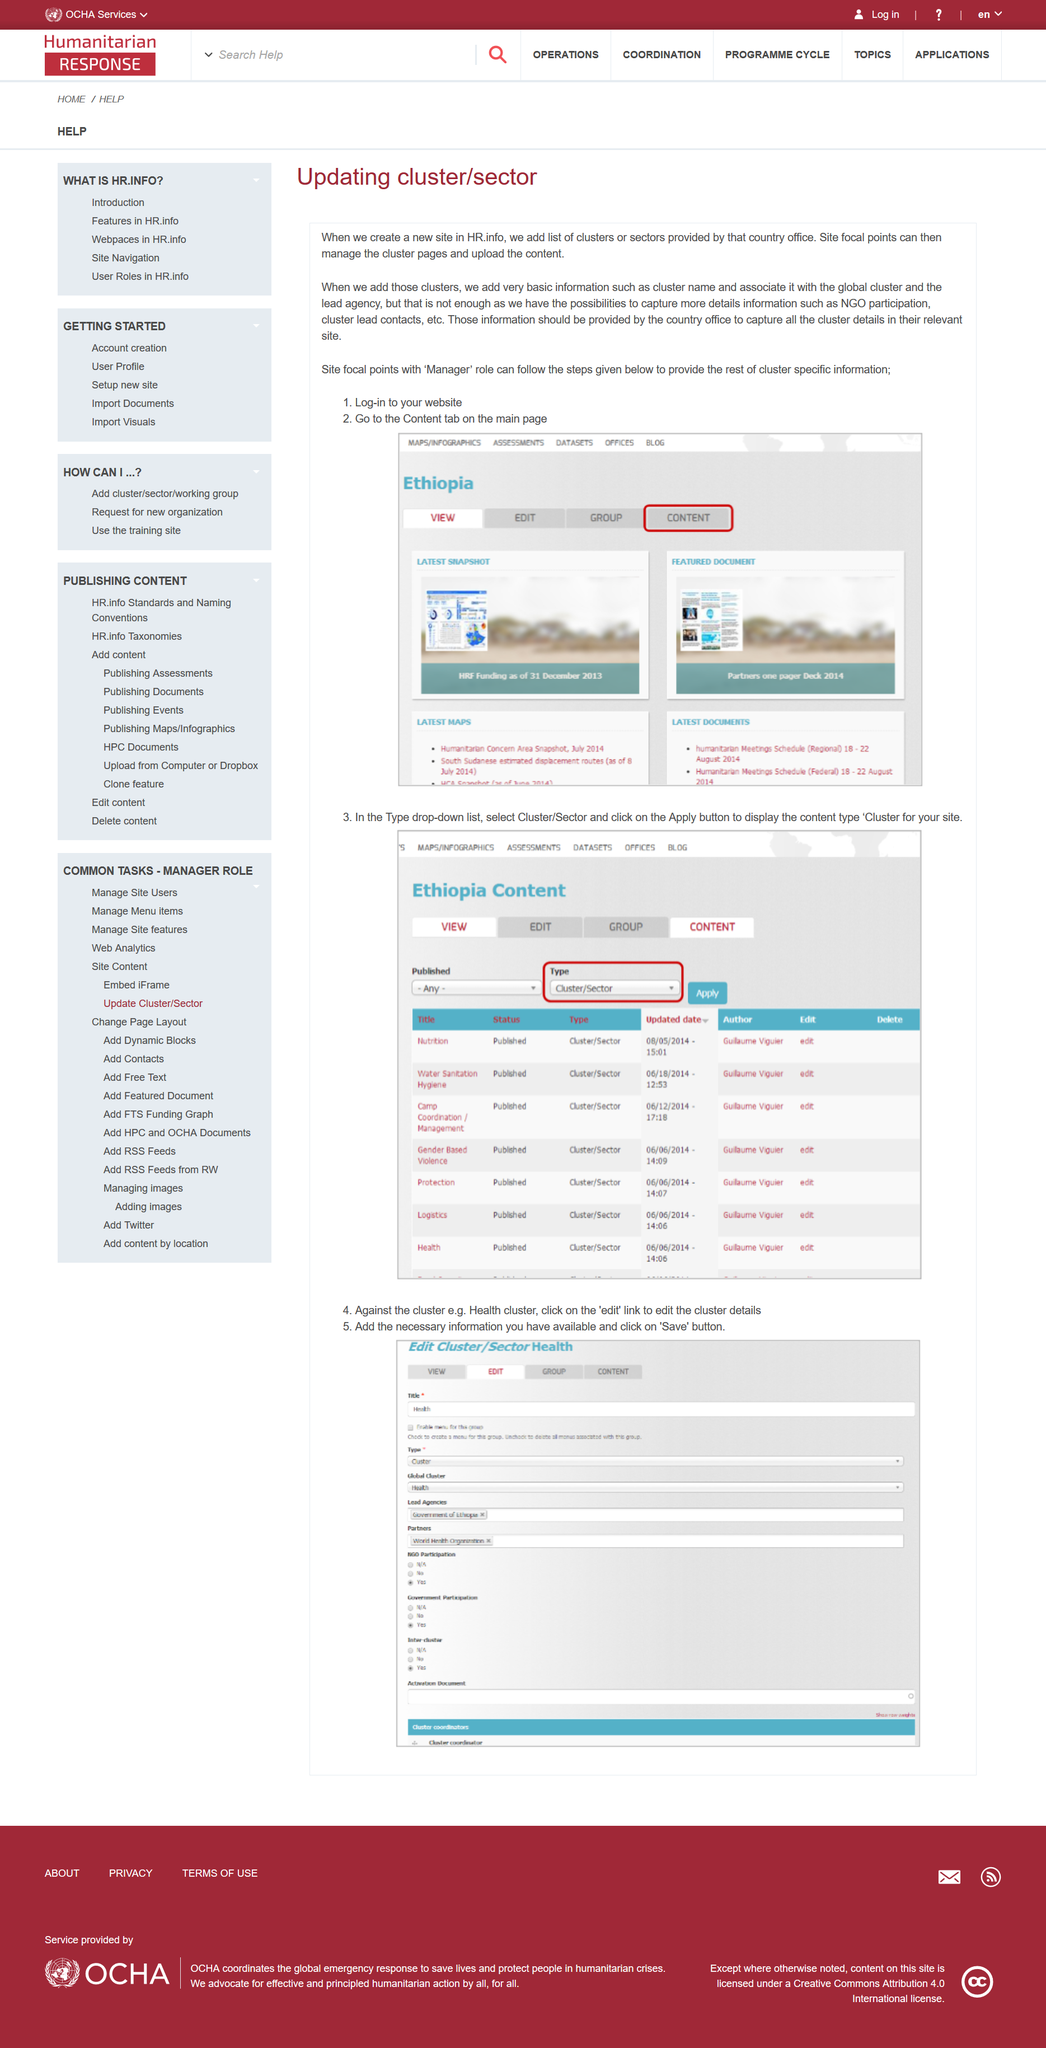Point out several critical features in this image. When a new site is created in HR.info, a list of clusters or sectors is added. After logging into their website, managers go to the Content tab on the main page. The relevant country office should provide all the information for the new sites. 